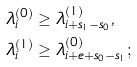<formula> <loc_0><loc_0><loc_500><loc_500>& \lambda _ { i } ^ { ( 0 ) } \geq { \lambda ^ { ( 1 ) } _ { i + s _ { 1 } - s _ { 0 } } } , \\ & \lambda ^ { ( 1 ) } _ { i } \geq { \lambda ^ { ( 0 ) } _ { i + e + s _ { 0 } - s _ { 1 } } } ;</formula> 